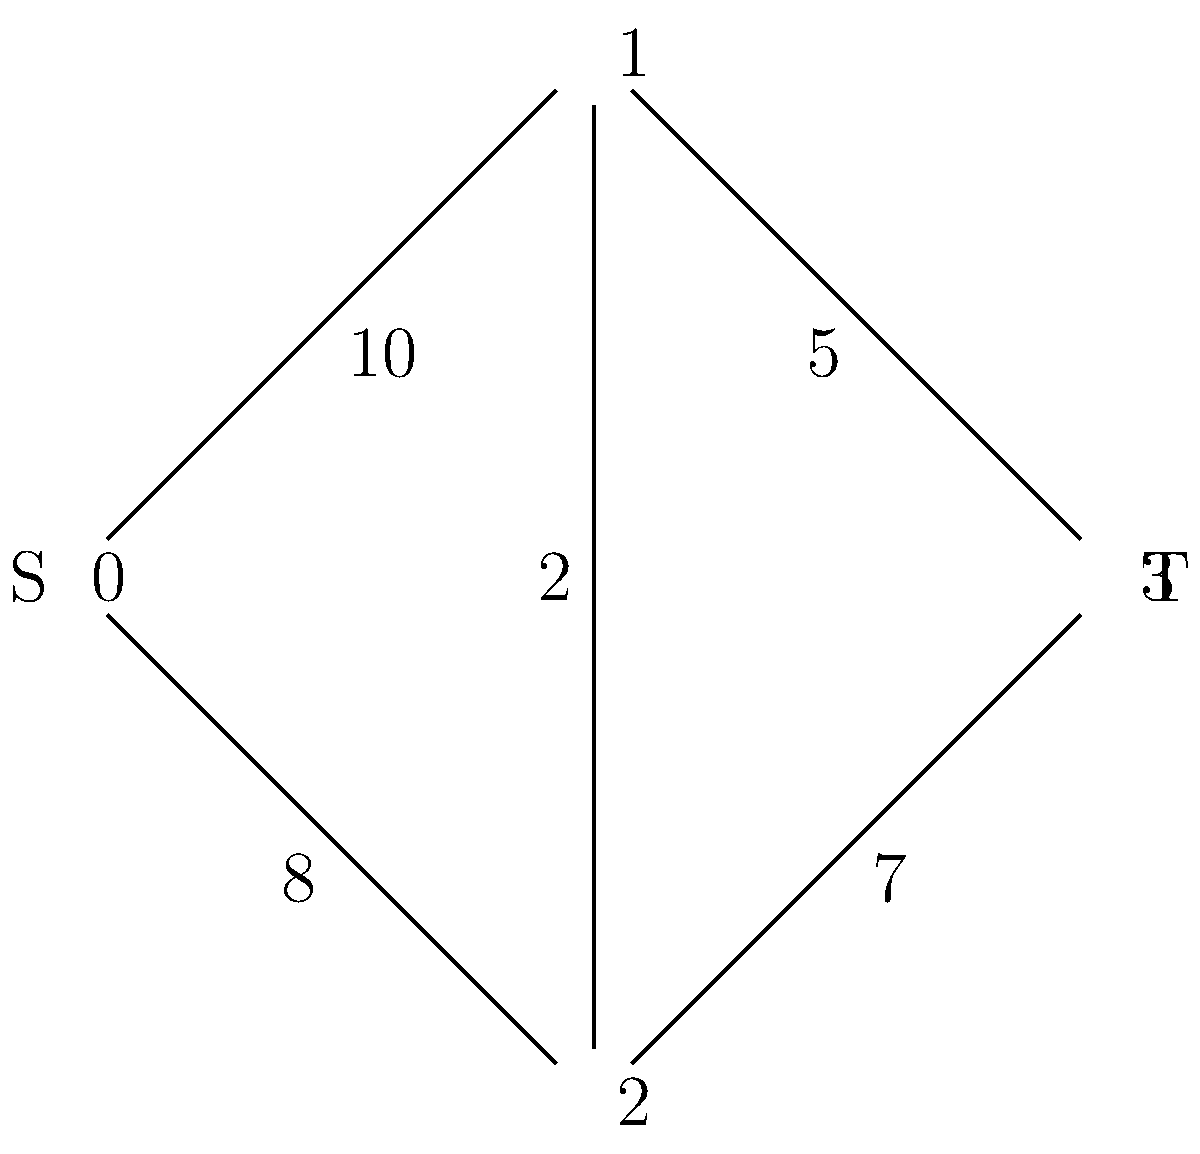Given the network flow graph representing data access patterns in a digital repository, what is the maximum flow from source S (node 0) to sink T (node 3)? Assume all edges are directed from left to right. To solve this maximum flow problem, we'll use the Ford-Fulkerson algorithm:

1) Initialize flow to 0 for all edges.

2) Find an augmenting path from S to T:
   Path 1: S → 1 → T (min capacity 5)
   Increase flow by 5. Remaining capacities:
   S → 1: 5, 1 → T: 0, S → 2: 8, 2 → T: 7, 1 → 2: 2

3) Find another augmenting path:
   Path 2: S → 2 → T (min capacity 7)
   Increase flow by 7. Remaining capacities:
   S → 1: 5, 1 → T: 0, S → 2: 1, 2 → T: 0, 1 → 2: 2

4) Find another augmenting path:
   Path 3: S → 1 → 2 → T (min capacity 1)
   Increase flow by 1. Remaining capacities:
   S → 1: 4, 1 → T: 0, S → 2: 1, 2 → T: 0, 1 → 2: 1

5) No more augmenting paths exist.

The maximum flow is the sum of all flow increases:
$5 + 7 + 1 = 13$
Answer: 13 